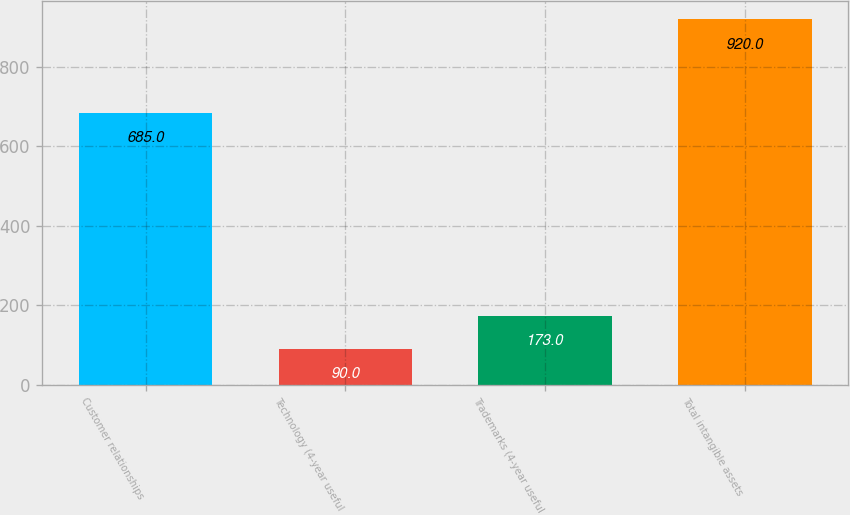<chart> <loc_0><loc_0><loc_500><loc_500><bar_chart><fcel>Customer relationships<fcel>Technology (4-year useful<fcel>Trademarks (4-year useful<fcel>Total intangible assets<nl><fcel>685<fcel>90<fcel>173<fcel>920<nl></chart> 